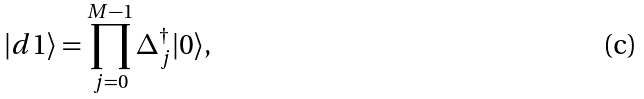Convert formula to latex. <formula><loc_0><loc_0><loc_500><loc_500>| d 1 \rangle = \prod _ { j = 0 } ^ { M - 1 } \Delta _ { j } ^ { \dagger } | 0 \rangle ,</formula> 